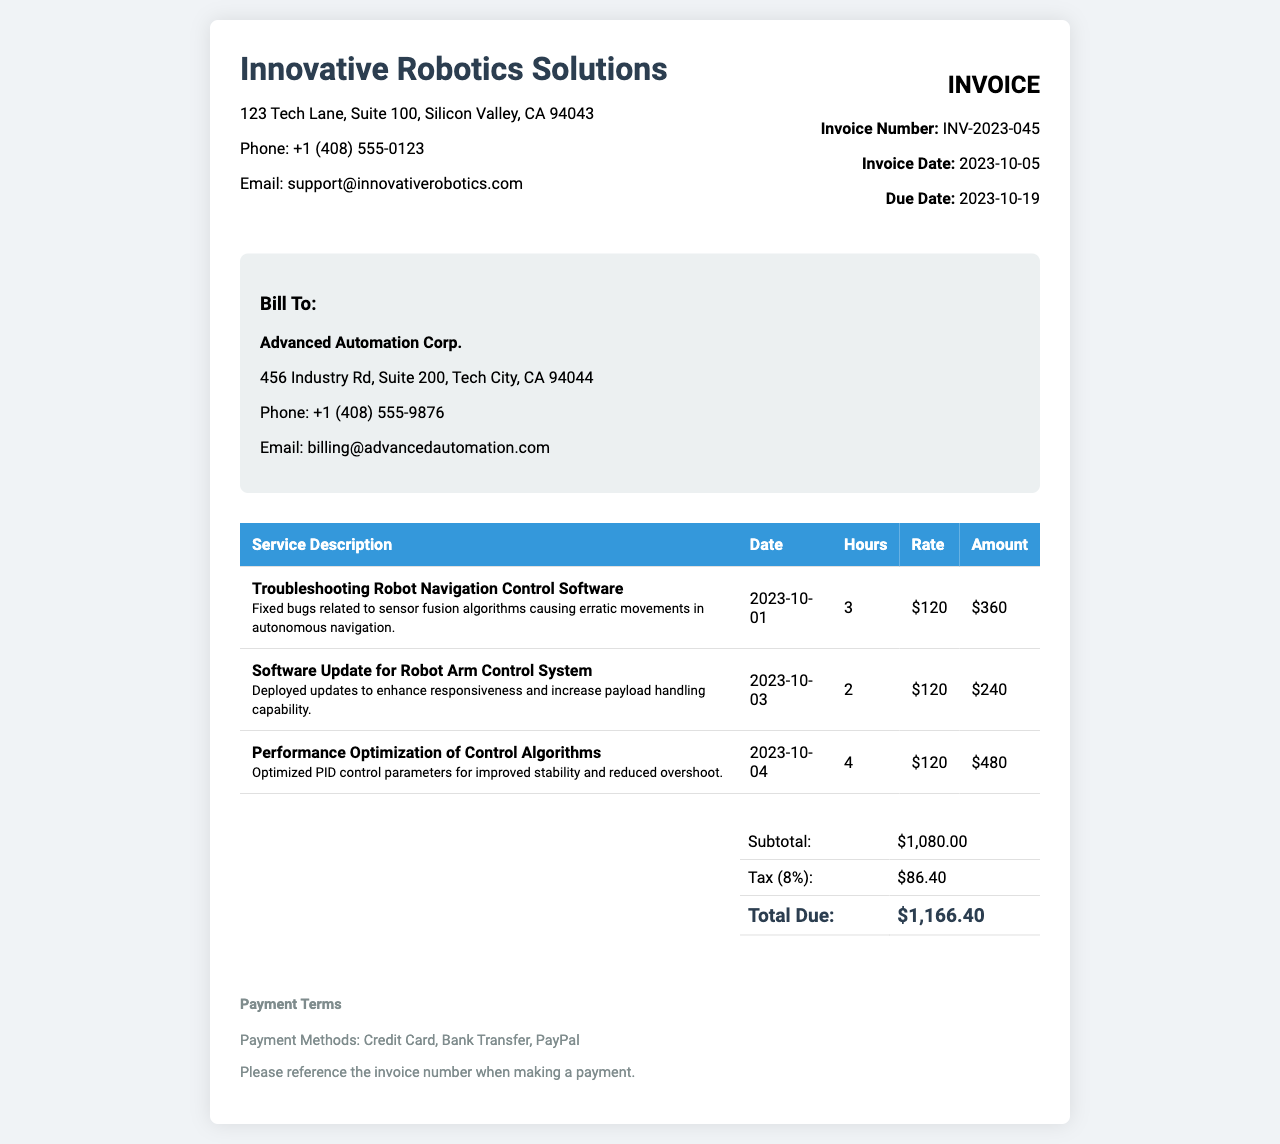what is the invoice number? The invoice number is a unique identifier for the invoice, found in the invoice info section.
Answer: INV-2023-045 what is the total due? The total due is the amount that needs to be paid, calculated after including taxes.
Answer: $1,166.40 who is the client? The client is the entity being billed for the services rendered, mentioned in the billing section.
Answer: Advanced Automation Corp what was the date of the software update for the Robot Arm Control System? The date indicates when a specific service was provided, found in the service description table.
Answer: 2023-10-03 how many hours were spent on performance optimization of control algorithms? The hours represent the duration spent on a specific service, displayed in the service details.
Answer: 4 what was the subtotal before tax? The subtotal is the sum of all services before adding tax, as listed in the summary section.
Answer: $1,080.00 what is the date of the invoice? The date of the invoice indicates when it was issued, found in the invoice info section.
Answer: 2023-10-05 what issues were fixed in the robot navigation control software? The explanation provides insight into what problems were addressed during the service.
Answer: Erratic movements in autonomous navigation what is the payment method listed? The payment methods are specified towards the end of the invoice, detailing how payments can be made.
Answer: Credit Card, Bank Transfer, PayPal 